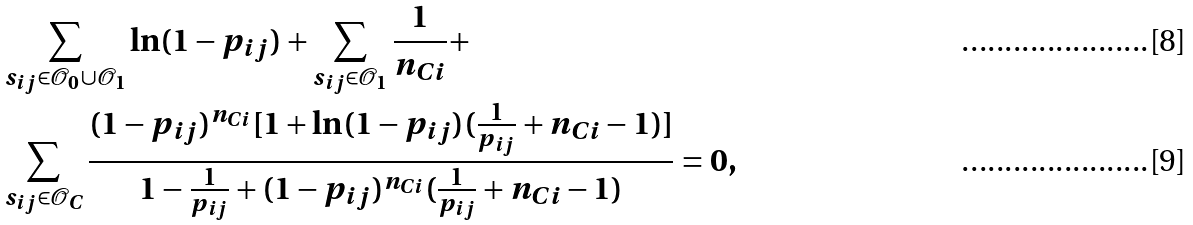Convert formula to latex. <formula><loc_0><loc_0><loc_500><loc_500>& \sum _ { s _ { i j } \in { \mathcal { O } _ { 0 } } \cup \mathcal { O } _ { 1 } } \ln ( 1 - p _ { i j } ) + \sum _ { s _ { i j } \in \mathcal { O } _ { 1 } } \frac { 1 } { n _ { C i } } + \\ & \sum _ { s _ { i j } \in \mathcal { O } _ { C } } \frac { ( 1 - p _ { i j } ) ^ { n _ { C i } } [ 1 + \ln ( 1 - p _ { i j } ) ( \frac { 1 } { p _ { i j } } + n _ { C i } - 1 ) ] } { 1 - \frac { 1 } { p _ { i j } } + ( 1 - p _ { i j } ) ^ { n _ { C i } } ( \frac { 1 } { p _ { i j } } + n _ { C i } - 1 ) } = 0 ,</formula> 